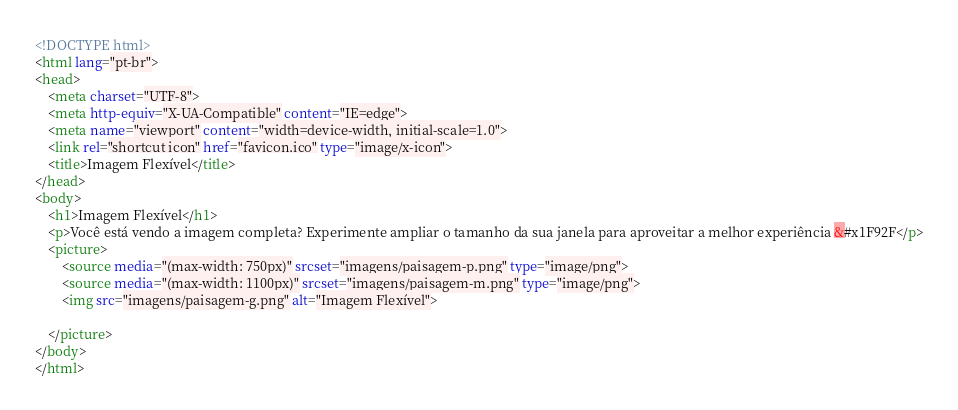<code> <loc_0><loc_0><loc_500><loc_500><_HTML_><!DOCTYPE html>
<html lang="pt-br">
<head>
    <meta charset="UTF-8">
    <meta http-equiv="X-UA-Compatible" content="IE=edge">
    <meta name="viewport" content="width=device-width, initial-scale=1.0">
    <link rel="shortcut icon" href="favicon.ico" type="image/x-icon">
    <title>Imagem Flexível</title>
</head>
<body>
    <h1>Imagem Flexível</h1>
    <p>Você está vendo a imagem completa? Experimente ampliar o tamanho da sua janela para aproveitar a melhor experiência &#x1F92F</p>
    <picture>
        <source media="(max-width: 750px)" srcset="imagens/paisagem-p.png" type="image/png">
        <source media="(max-width: 1100px)" srcset="imagens/paisagem-m.png" type="image/png">
        <img src="imagens/paisagem-g.png" alt="Imagem Flexível">
        
    </picture>
</body>
</html></code> 